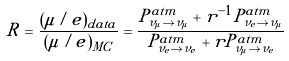<formula> <loc_0><loc_0><loc_500><loc_500>R = \frac { ( \mu / e ) _ { d a t a } } { ( \mu / e ) _ { M C } } = \frac { P ^ { a t m } _ { \nu _ { \mu } \to \nu _ { \mu } } + r ^ { - 1 } P ^ { a t m } _ { \nu _ { e } \to \nu _ { \mu } } } { P ^ { a t m } _ { \nu _ { e } \to \nu _ { e } } + r P ^ { a t m } _ { \nu _ { \mu } \to \nu _ { e } } }</formula> 